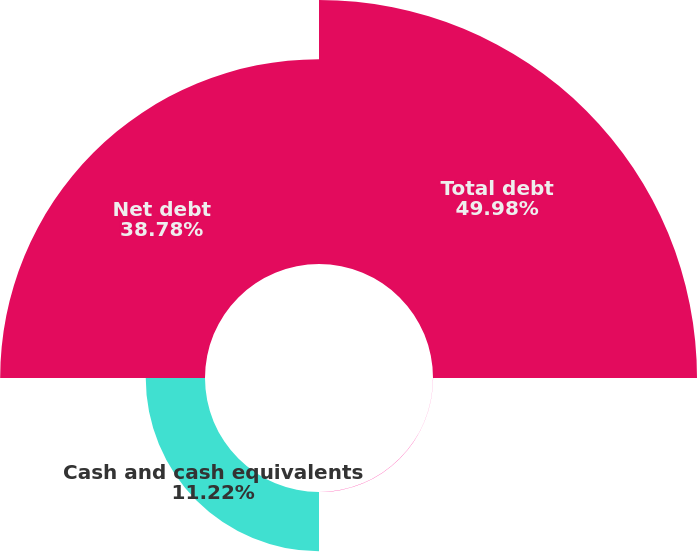Convert chart to OTSL. <chart><loc_0><loc_0><loc_500><loc_500><pie_chart><fcel>Total debt<fcel>Deferred gain on interest rate<fcel>Cash and cash equivalents<fcel>Net debt<nl><fcel>49.98%<fcel>0.02%<fcel>11.22%<fcel>38.78%<nl></chart> 